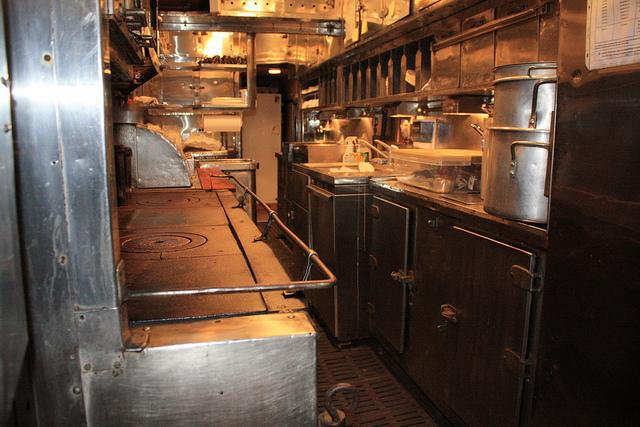What kind of setting is this venue? Please explain your reasoning. commercial kitchen. This has large pots and a big cooking surface plus it's mostly stainless steel 